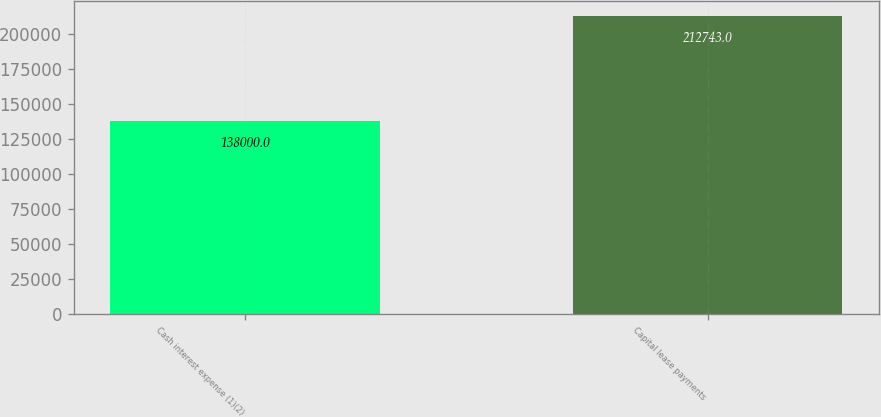Convert chart to OTSL. <chart><loc_0><loc_0><loc_500><loc_500><bar_chart><fcel>Cash interest expense (1)(2)<fcel>Capital lease payments<nl><fcel>138000<fcel>212743<nl></chart> 